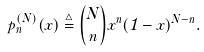<formula> <loc_0><loc_0><loc_500><loc_500>p _ { n } ^ { ( N ) } ( x ) \stackrel { \triangle } { = } { N \choose n } x ^ { n } ( 1 - x ) ^ { N - n } .</formula> 